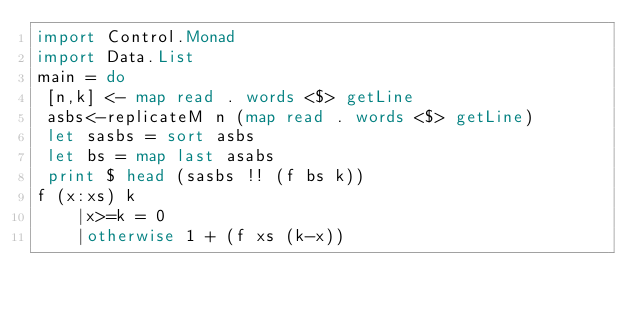Convert code to text. <code><loc_0><loc_0><loc_500><loc_500><_Haskell_>import Control.Monad
import Data.List
main = do
 [n,k] <- map read . words <$> getLine
 asbs<-replicateM n (map read . words <$> getLine)
 let sasbs = sort asbs
 let bs = map last asabs
 print $ head (sasbs !! (f bs k))
f (x:xs) k
    |x>=k = 0
    |otherwise 1 + (f xs (k-x))

</code> 